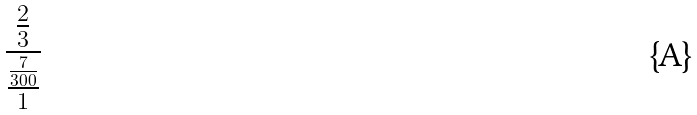<formula> <loc_0><loc_0><loc_500><loc_500>\frac { \frac { 2 } { 3 } } { \frac { \frac { 7 } { 3 0 0 } } { 1 } }</formula> 